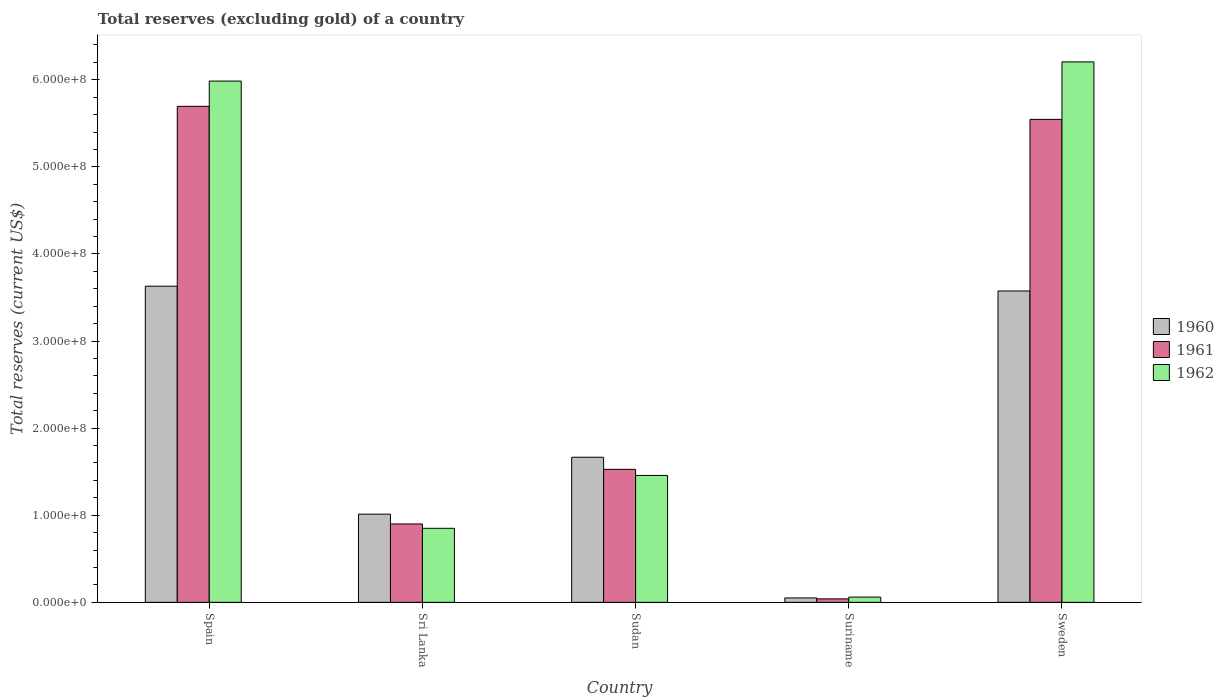How many groups of bars are there?
Keep it short and to the point. 5. Are the number of bars per tick equal to the number of legend labels?
Your response must be concise. Yes. Are the number of bars on each tick of the X-axis equal?
Keep it short and to the point. Yes. How many bars are there on the 1st tick from the left?
Keep it short and to the point. 3. How many bars are there on the 5th tick from the right?
Provide a short and direct response. 3. What is the label of the 3rd group of bars from the left?
Offer a very short reply. Sudan. In how many cases, is the number of bars for a given country not equal to the number of legend labels?
Give a very brief answer. 0. What is the total reserves (excluding gold) in 1960 in Sweden?
Give a very brief answer. 3.58e+08. Across all countries, what is the maximum total reserves (excluding gold) in 1962?
Your answer should be compact. 6.21e+08. Across all countries, what is the minimum total reserves (excluding gold) in 1961?
Give a very brief answer. 3.96e+06. In which country was the total reserves (excluding gold) in 1960 minimum?
Keep it short and to the point. Suriname. What is the total total reserves (excluding gold) in 1961 in the graph?
Offer a terse response. 1.37e+09. What is the difference between the total reserves (excluding gold) in 1962 in Sudan and that in Suriname?
Your answer should be compact. 1.40e+08. What is the difference between the total reserves (excluding gold) in 1961 in Sudan and the total reserves (excluding gold) in 1960 in Spain?
Give a very brief answer. -2.10e+08. What is the average total reserves (excluding gold) in 1962 per country?
Offer a very short reply. 2.91e+08. What is the difference between the total reserves (excluding gold) of/in 1960 and total reserves (excluding gold) of/in 1962 in Sri Lanka?
Your response must be concise. 1.63e+07. In how many countries, is the total reserves (excluding gold) in 1962 greater than 260000000 US$?
Make the answer very short. 2. What is the ratio of the total reserves (excluding gold) in 1960 in Sri Lanka to that in Suriname?
Give a very brief answer. 20.08. Is the difference between the total reserves (excluding gold) in 1960 in Suriname and Sweden greater than the difference between the total reserves (excluding gold) in 1962 in Suriname and Sweden?
Your response must be concise. Yes. What is the difference between the highest and the second highest total reserves (excluding gold) in 1962?
Give a very brief answer. 4.53e+08. What is the difference between the highest and the lowest total reserves (excluding gold) in 1961?
Keep it short and to the point. 5.66e+08. Is it the case that in every country, the sum of the total reserves (excluding gold) in 1962 and total reserves (excluding gold) in 1961 is greater than the total reserves (excluding gold) in 1960?
Keep it short and to the point. Yes. How many bars are there?
Your answer should be very brief. 15. Does the graph contain grids?
Provide a short and direct response. No. How are the legend labels stacked?
Your answer should be compact. Vertical. What is the title of the graph?
Keep it short and to the point. Total reserves (excluding gold) of a country. What is the label or title of the Y-axis?
Provide a succinct answer. Total reserves (current US$). What is the Total reserves (current US$) in 1960 in Spain?
Offer a terse response. 3.63e+08. What is the Total reserves (current US$) of 1961 in Spain?
Your response must be concise. 5.70e+08. What is the Total reserves (current US$) in 1962 in Spain?
Your answer should be very brief. 5.98e+08. What is the Total reserves (current US$) of 1960 in Sri Lanka?
Your answer should be compact. 1.01e+08. What is the Total reserves (current US$) of 1961 in Sri Lanka?
Offer a very short reply. 9.00e+07. What is the Total reserves (current US$) in 1962 in Sri Lanka?
Your answer should be compact. 8.50e+07. What is the Total reserves (current US$) of 1960 in Sudan?
Ensure brevity in your answer.  1.67e+08. What is the Total reserves (current US$) in 1961 in Sudan?
Keep it short and to the point. 1.53e+08. What is the Total reserves (current US$) of 1962 in Sudan?
Provide a short and direct response. 1.46e+08. What is the Total reserves (current US$) of 1960 in Suriname?
Offer a very short reply. 5.04e+06. What is the Total reserves (current US$) in 1961 in Suriname?
Give a very brief answer. 3.96e+06. What is the Total reserves (current US$) in 1962 in Suriname?
Ensure brevity in your answer.  6.01e+06. What is the Total reserves (current US$) in 1960 in Sweden?
Keep it short and to the point. 3.58e+08. What is the Total reserves (current US$) in 1961 in Sweden?
Your answer should be very brief. 5.55e+08. What is the Total reserves (current US$) in 1962 in Sweden?
Your answer should be compact. 6.21e+08. Across all countries, what is the maximum Total reserves (current US$) of 1960?
Give a very brief answer. 3.63e+08. Across all countries, what is the maximum Total reserves (current US$) in 1961?
Provide a short and direct response. 5.70e+08. Across all countries, what is the maximum Total reserves (current US$) in 1962?
Make the answer very short. 6.21e+08. Across all countries, what is the minimum Total reserves (current US$) of 1960?
Offer a terse response. 5.04e+06. Across all countries, what is the minimum Total reserves (current US$) in 1961?
Ensure brevity in your answer.  3.96e+06. Across all countries, what is the minimum Total reserves (current US$) in 1962?
Keep it short and to the point. 6.01e+06. What is the total Total reserves (current US$) in 1960 in the graph?
Provide a succinct answer. 9.93e+08. What is the total Total reserves (current US$) in 1961 in the graph?
Ensure brevity in your answer.  1.37e+09. What is the total Total reserves (current US$) of 1962 in the graph?
Make the answer very short. 1.46e+09. What is the difference between the Total reserves (current US$) of 1960 in Spain and that in Sri Lanka?
Provide a short and direct response. 2.62e+08. What is the difference between the Total reserves (current US$) of 1961 in Spain and that in Sri Lanka?
Give a very brief answer. 4.80e+08. What is the difference between the Total reserves (current US$) of 1962 in Spain and that in Sri Lanka?
Your answer should be compact. 5.13e+08. What is the difference between the Total reserves (current US$) of 1960 in Spain and that in Sudan?
Give a very brief answer. 1.96e+08. What is the difference between the Total reserves (current US$) of 1961 in Spain and that in Sudan?
Your response must be concise. 4.17e+08. What is the difference between the Total reserves (current US$) of 1962 in Spain and that in Sudan?
Keep it short and to the point. 4.53e+08. What is the difference between the Total reserves (current US$) in 1960 in Spain and that in Suriname?
Your response must be concise. 3.58e+08. What is the difference between the Total reserves (current US$) of 1961 in Spain and that in Suriname?
Keep it short and to the point. 5.66e+08. What is the difference between the Total reserves (current US$) of 1962 in Spain and that in Suriname?
Offer a very short reply. 5.92e+08. What is the difference between the Total reserves (current US$) of 1960 in Spain and that in Sweden?
Give a very brief answer. 5.47e+06. What is the difference between the Total reserves (current US$) of 1961 in Spain and that in Sweden?
Your answer should be very brief. 1.50e+07. What is the difference between the Total reserves (current US$) of 1962 in Spain and that in Sweden?
Provide a short and direct response. -2.20e+07. What is the difference between the Total reserves (current US$) in 1960 in Sri Lanka and that in Sudan?
Give a very brief answer. -6.53e+07. What is the difference between the Total reserves (current US$) in 1961 in Sri Lanka and that in Sudan?
Your answer should be very brief. -6.27e+07. What is the difference between the Total reserves (current US$) in 1962 in Sri Lanka and that in Sudan?
Offer a very short reply. -6.07e+07. What is the difference between the Total reserves (current US$) of 1960 in Sri Lanka and that in Suriname?
Your answer should be very brief. 9.62e+07. What is the difference between the Total reserves (current US$) in 1961 in Sri Lanka and that in Suriname?
Keep it short and to the point. 8.60e+07. What is the difference between the Total reserves (current US$) of 1962 in Sri Lanka and that in Suriname?
Keep it short and to the point. 7.90e+07. What is the difference between the Total reserves (current US$) in 1960 in Sri Lanka and that in Sweden?
Give a very brief answer. -2.56e+08. What is the difference between the Total reserves (current US$) in 1961 in Sri Lanka and that in Sweden?
Give a very brief answer. -4.65e+08. What is the difference between the Total reserves (current US$) of 1962 in Sri Lanka and that in Sweden?
Offer a terse response. -5.36e+08. What is the difference between the Total reserves (current US$) of 1960 in Sudan and that in Suriname?
Provide a succinct answer. 1.62e+08. What is the difference between the Total reserves (current US$) of 1961 in Sudan and that in Suriname?
Provide a short and direct response. 1.49e+08. What is the difference between the Total reserves (current US$) of 1962 in Sudan and that in Suriname?
Offer a very short reply. 1.40e+08. What is the difference between the Total reserves (current US$) in 1960 in Sudan and that in Sweden?
Ensure brevity in your answer.  -1.91e+08. What is the difference between the Total reserves (current US$) of 1961 in Sudan and that in Sweden?
Keep it short and to the point. -4.02e+08. What is the difference between the Total reserves (current US$) of 1962 in Sudan and that in Sweden?
Provide a short and direct response. -4.75e+08. What is the difference between the Total reserves (current US$) of 1960 in Suriname and that in Sweden?
Provide a succinct answer. -3.52e+08. What is the difference between the Total reserves (current US$) in 1961 in Suriname and that in Sweden?
Your answer should be very brief. -5.51e+08. What is the difference between the Total reserves (current US$) in 1962 in Suriname and that in Sweden?
Provide a short and direct response. -6.15e+08. What is the difference between the Total reserves (current US$) in 1960 in Spain and the Total reserves (current US$) in 1961 in Sri Lanka?
Make the answer very short. 2.73e+08. What is the difference between the Total reserves (current US$) of 1960 in Spain and the Total reserves (current US$) of 1962 in Sri Lanka?
Ensure brevity in your answer.  2.78e+08. What is the difference between the Total reserves (current US$) in 1961 in Spain and the Total reserves (current US$) in 1962 in Sri Lanka?
Provide a succinct answer. 4.85e+08. What is the difference between the Total reserves (current US$) of 1960 in Spain and the Total reserves (current US$) of 1961 in Sudan?
Provide a succinct answer. 2.10e+08. What is the difference between the Total reserves (current US$) of 1960 in Spain and the Total reserves (current US$) of 1962 in Sudan?
Offer a terse response. 2.17e+08. What is the difference between the Total reserves (current US$) of 1961 in Spain and the Total reserves (current US$) of 1962 in Sudan?
Give a very brief answer. 4.24e+08. What is the difference between the Total reserves (current US$) of 1960 in Spain and the Total reserves (current US$) of 1961 in Suriname?
Provide a short and direct response. 3.59e+08. What is the difference between the Total reserves (current US$) of 1960 in Spain and the Total reserves (current US$) of 1962 in Suriname?
Give a very brief answer. 3.57e+08. What is the difference between the Total reserves (current US$) in 1961 in Spain and the Total reserves (current US$) in 1962 in Suriname?
Offer a very short reply. 5.64e+08. What is the difference between the Total reserves (current US$) in 1960 in Spain and the Total reserves (current US$) in 1961 in Sweden?
Give a very brief answer. -1.92e+08. What is the difference between the Total reserves (current US$) in 1960 in Spain and the Total reserves (current US$) in 1962 in Sweden?
Ensure brevity in your answer.  -2.58e+08. What is the difference between the Total reserves (current US$) in 1961 in Spain and the Total reserves (current US$) in 1962 in Sweden?
Ensure brevity in your answer.  -5.10e+07. What is the difference between the Total reserves (current US$) in 1960 in Sri Lanka and the Total reserves (current US$) in 1961 in Sudan?
Offer a terse response. -5.14e+07. What is the difference between the Total reserves (current US$) in 1960 in Sri Lanka and the Total reserves (current US$) in 1962 in Sudan?
Keep it short and to the point. -4.44e+07. What is the difference between the Total reserves (current US$) in 1961 in Sri Lanka and the Total reserves (current US$) in 1962 in Sudan?
Provide a succinct answer. -5.57e+07. What is the difference between the Total reserves (current US$) in 1960 in Sri Lanka and the Total reserves (current US$) in 1961 in Suriname?
Offer a terse response. 9.73e+07. What is the difference between the Total reserves (current US$) of 1960 in Sri Lanka and the Total reserves (current US$) of 1962 in Suriname?
Ensure brevity in your answer.  9.52e+07. What is the difference between the Total reserves (current US$) in 1961 in Sri Lanka and the Total reserves (current US$) in 1962 in Suriname?
Offer a terse response. 8.40e+07. What is the difference between the Total reserves (current US$) of 1960 in Sri Lanka and the Total reserves (current US$) of 1961 in Sweden?
Provide a succinct answer. -4.53e+08. What is the difference between the Total reserves (current US$) of 1960 in Sri Lanka and the Total reserves (current US$) of 1962 in Sweden?
Your answer should be very brief. -5.19e+08. What is the difference between the Total reserves (current US$) of 1961 in Sri Lanka and the Total reserves (current US$) of 1962 in Sweden?
Ensure brevity in your answer.  -5.31e+08. What is the difference between the Total reserves (current US$) of 1960 in Sudan and the Total reserves (current US$) of 1961 in Suriname?
Your answer should be compact. 1.63e+08. What is the difference between the Total reserves (current US$) of 1960 in Sudan and the Total reserves (current US$) of 1962 in Suriname?
Provide a short and direct response. 1.61e+08. What is the difference between the Total reserves (current US$) of 1961 in Sudan and the Total reserves (current US$) of 1962 in Suriname?
Provide a succinct answer. 1.47e+08. What is the difference between the Total reserves (current US$) in 1960 in Sudan and the Total reserves (current US$) in 1961 in Sweden?
Provide a short and direct response. -3.88e+08. What is the difference between the Total reserves (current US$) in 1960 in Sudan and the Total reserves (current US$) in 1962 in Sweden?
Offer a very short reply. -4.54e+08. What is the difference between the Total reserves (current US$) of 1961 in Sudan and the Total reserves (current US$) of 1962 in Sweden?
Your response must be concise. -4.68e+08. What is the difference between the Total reserves (current US$) in 1960 in Suriname and the Total reserves (current US$) in 1961 in Sweden?
Give a very brief answer. -5.49e+08. What is the difference between the Total reserves (current US$) in 1960 in Suriname and the Total reserves (current US$) in 1962 in Sweden?
Offer a terse response. -6.15e+08. What is the difference between the Total reserves (current US$) in 1961 in Suriname and the Total reserves (current US$) in 1962 in Sweden?
Ensure brevity in your answer.  -6.17e+08. What is the average Total reserves (current US$) in 1960 per country?
Your answer should be compact. 1.99e+08. What is the average Total reserves (current US$) of 1961 per country?
Keep it short and to the point. 2.74e+08. What is the average Total reserves (current US$) of 1962 per country?
Offer a very short reply. 2.91e+08. What is the difference between the Total reserves (current US$) in 1960 and Total reserves (current US$) in 1961 in Spain?
Offer a very short reply. -2.07e+08. What is the difference between the Total reserves (current US$) in 1960 and Total reserves (current US$) in 1962 in Spain?
Keep it short and to the point. -2.35e+08. What is the difference between the Total reserves (current US$) of 1961 and Total reserves (current US$) of 1962 in Spain?
Provide a succinct answer. -2.90e+07. What is the difference between the Total reserves (current US$) of 1960 and Total reserves (current US$) of 1961 in Sri Lanka?
Ensure brevity in your answer.  1.13e+07. What is the difference between the Total reserves (current US$) in 1960 and Total reserves (current US$) in 1962 in Sri Lanka?
Ensure brevity in your answer.  1.63e+07. What is the difference between the Total reserves (current US$) of 1960 and Total reserves (current US$) of 1961 in Sudan?
Your answer should be compact. 1.39e+07. What is the difference between the Total reserves (current US$) in 1960 and Total reserves (current US$) in 1962 in Sudan?
Your response must be concise. 2.09e+07. What is the difference between the Total reserves (current US$) in 1961 and Total reserves (current US$) in 1962 in Sudan?
Your response must be concise. 7.00e+06. What is the difference between the Total reserves (current US$) in 1960 and Total reserves (current US$) in 1961 in Suriname?
Ensure brevity in your answer.  1.08e+06. What is the difference between the Total reserves (current US$) of 1960 and Total reserves (current US$) of 1962 in Suriname?
Your response must be concise. -9.68e+05. What is the difference between the Total reserves (current US$) in 1961 and Total reserves (current US$) in 1962 in Suriname?
Offer a terse response. -2.05e+06. What is the difference between the Total reserves (current US$) in 1960 and Total reserves (current US$) in 1961 in Sweden?
Ensure brevity in your answer.  -1.97e+08. What is the difference between the Total reserves (current US$) of 1960 and Total reserves (current US$) of 1962 in Sweden?
Keep it short and to the point. -2.63e+08. What is the difference between the Total reserves (current US$) of 1961 and Total reserves (current US$) of 1962 in Sweden?
Give a very brief answer. -6.60e+07. What is the ratio of the Total reserves (current US$) of 1960 in Spain to that in Sri Lanka?
Keep it short and to the point. 3.58. What is the ratio of the Total reserves (current US$) in 1961 in Spain to that in Sri Lanka?
Make the answer very short. 6.33. What is the ratio of the Total reserves (current US$) in 1962 in Spain to that in Sri Lanka?
Your response must be concise. 7.04. What is the ratio of the Total reserves (current US$) in 1960 in Spain to that in Sudan?
Your answer should be compact. 2.18. What is the ratio of the Total reserves (current US$) in 1961 in Spain to that in Sudan?
Offer a very short reply. 3.73. What is the ratio of the Total reserves (current US$) of 1962 in Spain to that in Sudan?
Provide a short and direct response. 4.11. What is the ratio of the Total reserves (current US$) in 1960 in Spain to that in Suriname?
Make the answer very short. 71.98. What is the ratio of the Total reserves (current US$) of 1961 in Spain to that in Suriname?
Offer a very short reply. 143.78. What is the ratio of the Total reserves (current US$) of 1962 in Spain to that in Suriname?
Make the answer very short. 99.57. What is the ratio of the Total reserves (current US$) in 1960 in Spain to that in Sweden?
Make the answer very short. 1.02. What is the ratio of the Total reserves (current US$) in 1962 in Spain to that in Sweden?
Keep it short and to the point. 0.96. What is the ratio of the Total reserves (current US$) in 1960 in Sri Lanka to that in Sudan?
Give a very brief answer. 0.61. What is the ratio of the Total reserves (current US$) of 1961 in Sri Lanka to that in Sudan?
Provide a succinct answer. 0.59. What is the ratio of the Total reserves (current US$) of 1962 in Sri Lanka to that in Sudan?
Keep it short and to the point. 0.58. What is the ratio of the Total reserves (current US$) of 1960 in Sri Lanka to that in Suriname?
Your answer should be compact. 20.08. What is the ratio of the Total reserves (current US$) in 1961 in Sri Lanka to that in Suriname?
Provide a short and direct response. 22.72. What is the ratio of the Total reserves (current US$) of 1962 in Sri Lanka to that in Suriname?
Your answer should be very brief. 14.14. What is the ratio of the Total reserves (current US$) of 1960 in Sri Lanka to that in Sweden?
Your response must be concise. 0.28. What is the ratio of the Total reserves (current US$) in 1961 in Sri Lanka to that in Sweden?
Ensure brevity in your answer.  0.16. What is the ratio of the Total reserves (current US$) in 1962 in Sri Lanka to that in Sweden?
Make the answer very short. 0.14. What is the ratio of the Total reserves (current US$) in 1960 in Sudan to that in Suriname?
Your answer should be very brief. 33.04. What is the ratio of the Total reserves (current US$) in 1961 in Sudan to that in Suriname?
Your answer should be compact. 38.55. What is the ratio of the Total reserves (current US$) in 1962 in Sudan to that in Suriname?
Provide a succinct answer. 24.24. What is the ratio of the Total reserves (current US$) of 1960 in Sudan to that in Sweden?
Offer a terse response. 0.47. What is the ratio of the Total reserves (current US$) of 1961 in Sudan to that in Sweden?
Your answer should be compact. 0.28. What is the ratio of the Total reserves (current US$) in 1962 in Sudan to that in Sweden?
Provide a succinct answer. 0.23. What is the ratio of the Total reserves (current US$) of 1960 in Suriname to that in Sweden?
Provide a succinct answer. 0.01. What is the ratio of the Total reserves (current US$) of 1961 in Suriname to that in Sweden?
Provide a short and direct response. 0.01. What is the ratio of the Total reserves (current US$) of 1962 in Suriname to that in Sweden?
Keep it short and to the point. 0.01. What is the difference between the highest and the second highest Total reserves (current US$) of 1960?
Make the answer very short. 5.47e+06. What is the difference between the highest and the second highest Total reserves (current US$) of 1961?
Offer a very short reply. 1.50e+07. What is the difference between the highest and the second highest Total reserves (current US$) in 1962?
Your response must be concise. 2.20e+07. What is the difference between the highest and the lowest Total reserves (current US$) of 1960?
Keep it short and to the point. 3.58e+08. What is the difference between the highest and the lowest Total reserves (current US$) in 1961?
Your answer should be compact. 5.66e+08. What is the difference between the highest and the lowest Total reserves (current US$) of 1962?
Make the answer very short. 6.15e+08. 